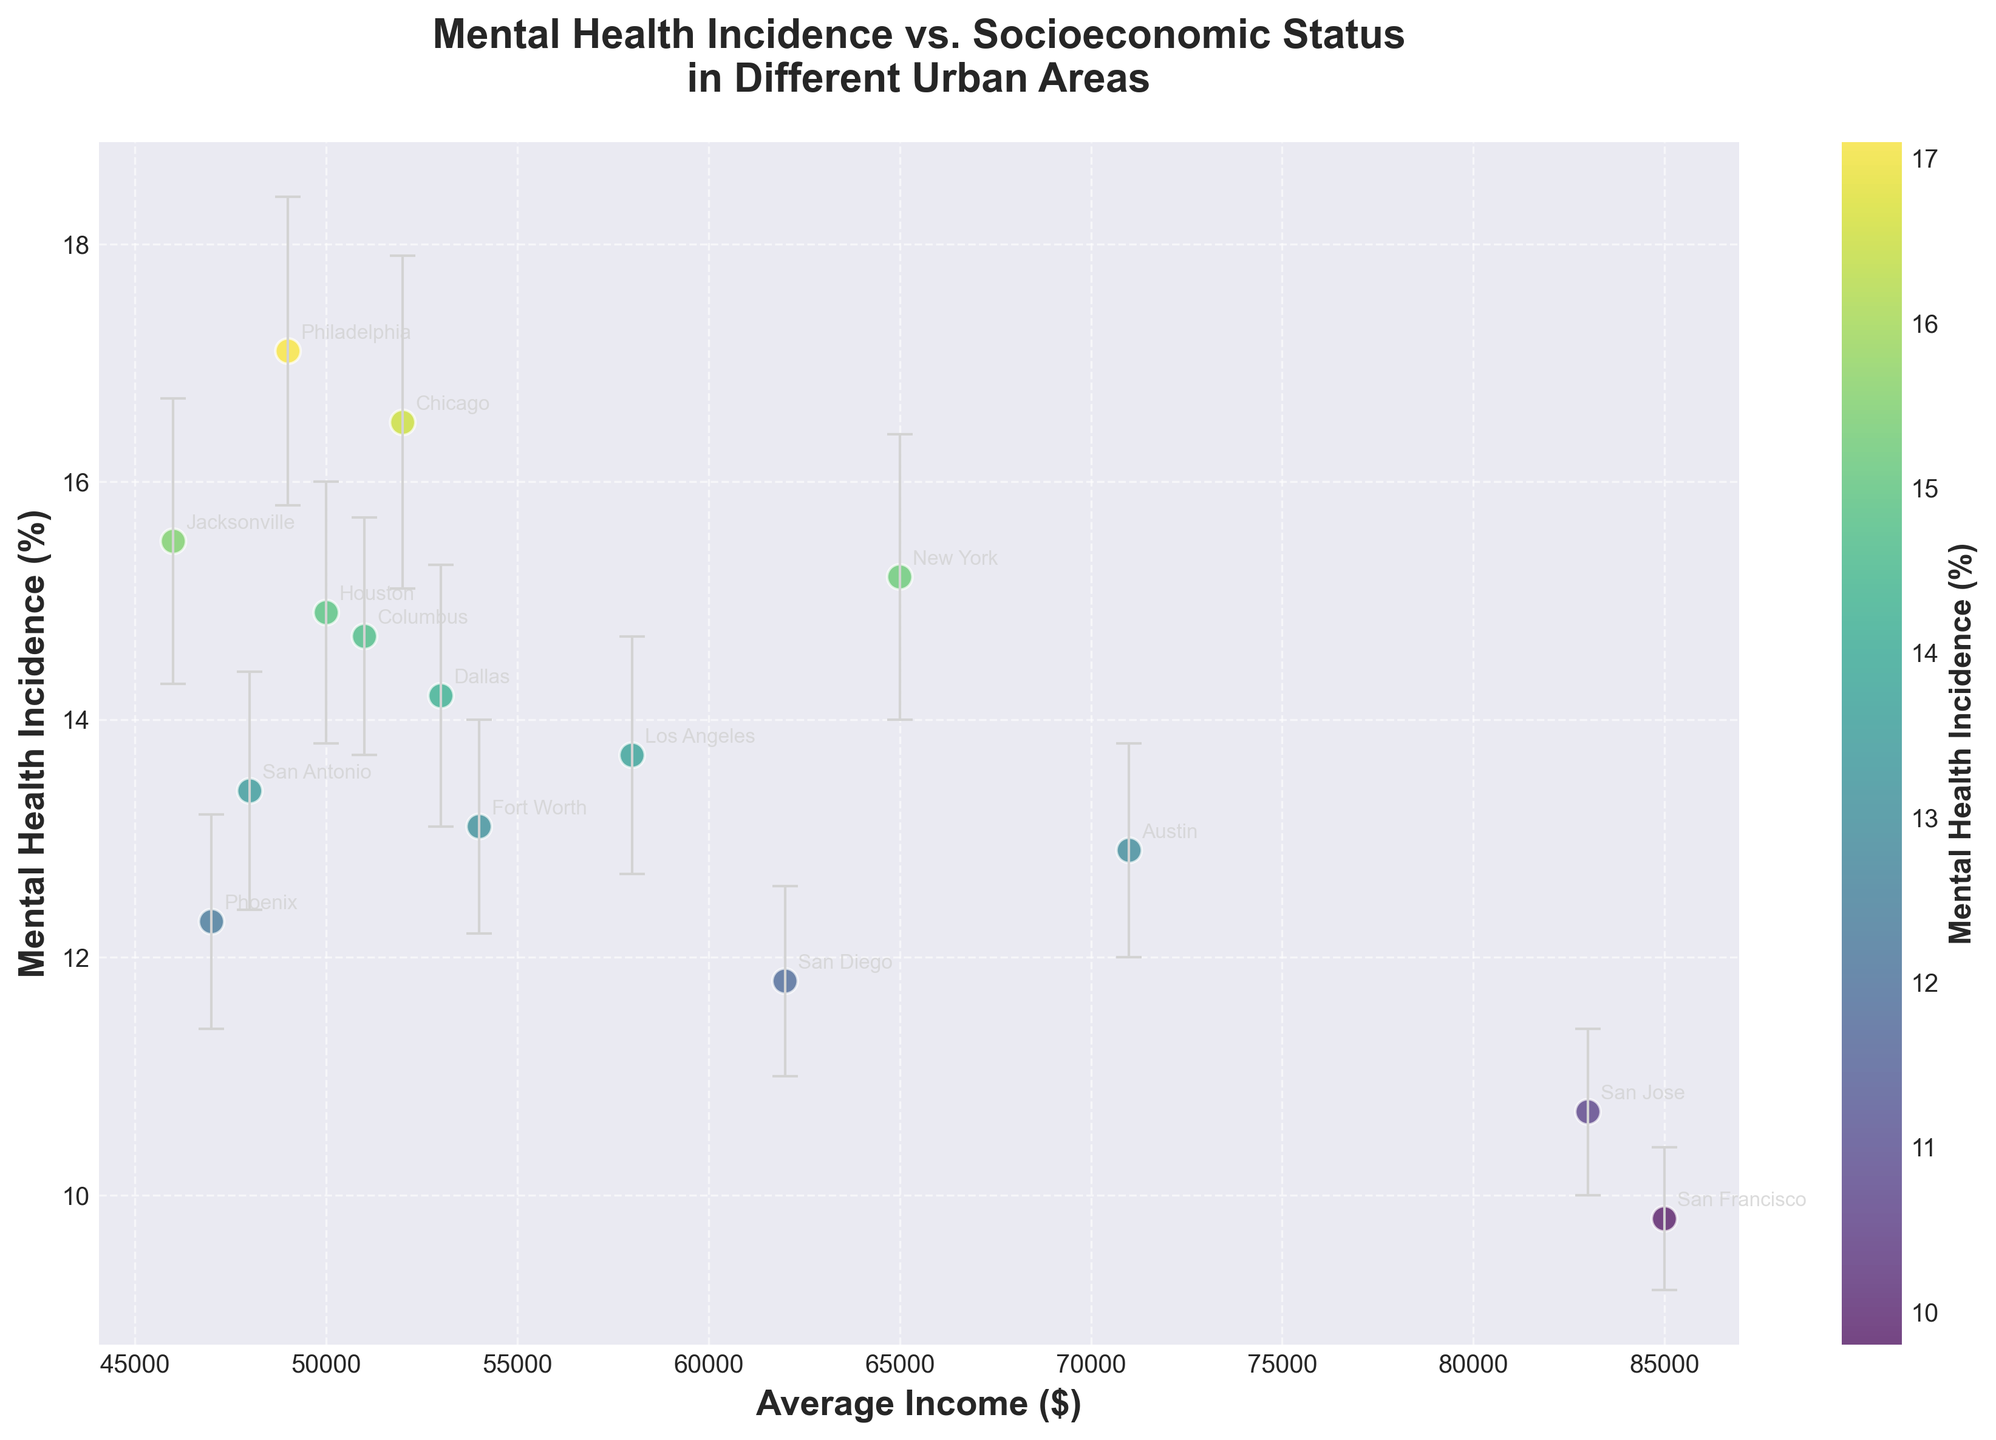What is the title of the figure? The title of the figure is displayed at the top and summarizes what the plot represents: "Mental Health Incidence vs. Socioeconomic Status in Different Urban Areas".
Answer: "Mental Health Incidence vs. Socioeconomic Status in Different Urban Areas" What is the average income in San Francisco? Identify the point labeled "San Francisco" in the plot and note the x-axis value corresponding to it. The label shows the average income.
Answer: 85,000 Which urban area has the highest mental health incidence? Find the highest point on the y-axis (Mental Health Incidence) and note the corresponding urban area label.
Answer: Philadelphia Which urban area has the lowest average income? Find the point on the far left of the x-axis (Average Income) and note the corresponding urban area label.
Answer: Jacksonville What is the range of mental health incidence in the dataset? Look for the highest and lowest points on the y-axis. The highest is for Philadelphia (17.1%) and the lowest for San Francisco (9.8%). Subtract the lowest value from the highest value.
Answer: 7.3% What can be inferred about the relationship between mental health incidence and average income? Analyze the spread and gradient of the points. Higher income urban areas like San Francisco and San Jose tend to have lower mental health incidence, while lower-income areas like Philadelphia and Jacksonville have higher incidence, suggesting an inverse relationship.
Answer: Inversely related Which urban areas have an average income above 60,000 and a mental health incidence below 13%? Identify points on the plot where the x-axis value (Average Income) is greater than 60,000, and the y-axis value (Mental Health Incidence) is below 13%. The urban areas meeting these conditions are San Jose, Austin, and San Diego.
Answer: San Jose, Austin, San Diego What is the mental health incidence rate in Los Angeles, and how does it compare to New York? Identify the points labeled "Los Angeles" and "New York" and check their y-axis values for Mental Health Incidence. Compare these values.
Answer: Los Angeles: 13.7%, New York: 15.2%; Los Angeles has a lower incidence If you were to focus on urban areas with an average income less than 50,000, which area has the lowest mental health incidence? Isolate points on the plot with an average income less than 50,000 on the x-axis and find the one with the lowest value on the y-axis (Mental Health Incidence).
Answer: Phoenix How does the mental health incidence in Houston compare to that in Chicago? Look at the y-axis values for both Houston and Chicago from the plot. Houston has a value of 14.9%, while Chicago has a value of 16.5%.
Answer: Houston is lower 